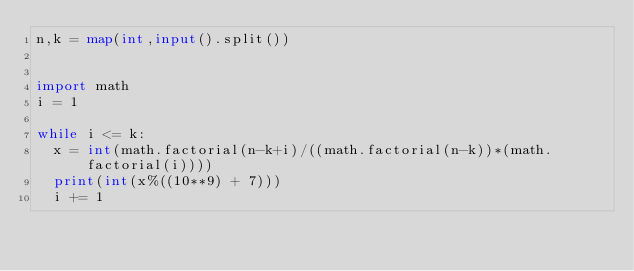<code> <loc_0><loc_0><loc_500><loc_500><_Python_>n,k = map(int,input().split())


import math
i = 1

while i <= k:
  x = int(math.factorial(n-k+i)/((math.factorial(n-k))*(math.factorial(i))))
  print(int(x%((10**9) + 7)))
  i += 1</code> 